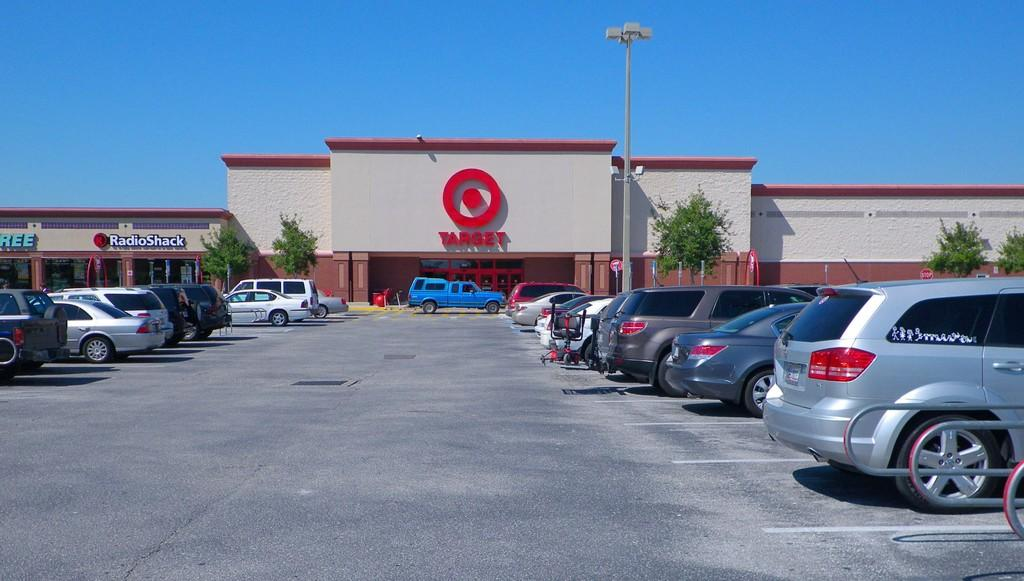What can be seen on the right side of the image? There are cars on the right side of the image. What can be seen on the left side of the image? There are cars on the left side of the image. What is located in the center of the image? There are buildings and a pole in the center of the image. What type of vegetation is present in the image? There are trees in the image. Can you tell me how many apples are on the pole in the image? There are no apples present in the image; the pole is not associated with any fruit. What role does the father play in the image? There is no mention of a father or any person in the image, so it is not possible to answer this question. 